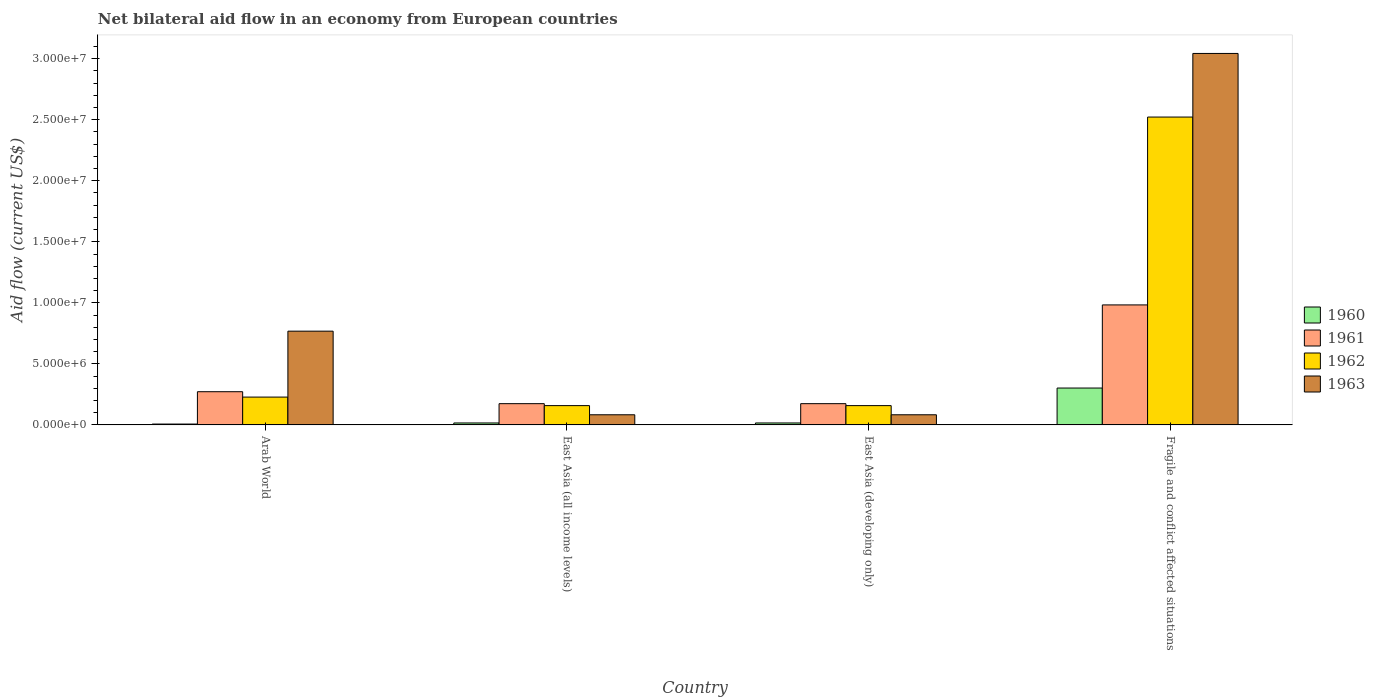How many bars are there on the 4th tick from the left?
Offer a terse response. 4. How many bars are there on the 3rd tick from the right?
Your response must be concise. 4. What is the label of the 2nd group of bars from the left?
Your answer should be compact. East Asia (all income levels). What is the net bilateral aid flow in 1962 in East Asia (developing only)?
Your answer should be compact. 1.58e+06. Across all countries, what is the maximum net bilateral aid flow in 1962?
Your answer should be very brief. 2.52e+07. Across all countries, what is the minimum net bilateral aid flow in 1963?
Provide a short and direct response. 8.30e+05. In which country was the net bilateral aid flow in 1962 maximum?
Offer a terse response. Fragile and conflict affected situations. In which country was the net bilateral aid flow in 1960 minimum?
Ensure brevity in your answer.  Arab World. What is the total net bilateral aid flow in 1961 in the graph?
Ensure brevity in your answer.  1.60e+07. What is the difference between the net bilateral aid flow in 1960 in Arab World and that in Fragile and conflict affected situations?
Your answer should be compact. -2.95e+06. What is the difference between the net bilateral aid flow in 1961 in Fragile and conflict affected situations and the net bilateral aid flow in 1963 in East Asia (all income levels)?
Give a very brief answer. 9.00e+06. What is the average net bilateral aid flow in 1960 per country?
Make the answer very short. 8.52e+05. What is the difference between the net bilateral aid flow of/in 1960 and net bilateral aid flow of/in 1963 in East Asia (developing only)?
Give a very brief answer. -6.70e+05. What is the ratio of the net bilateral aid flow in 1962 in Arab World to that in Fragile and conflict affected situations?
Provide a short and direct response. 0.09. Is the net bilateral aid flow in 1962 in East Asia (developing only) less than that in Fragile and conflict affected situations?
Provide a short and direct response. Yes. What is the difference between the highest and the second highest net bilateral aid flow in 1961?
Offer a terse response. 7.11e+06. What is the difference between the highest and the lowest net bilateral aid flow in 1961?
Your answer should be very brief. 8.09e+06. What does the 2nd bar from the left in Fragile and conflict affected situations represents?
Offer a very short reply. 1961. How many bars are there?
Give a very brief answer. 16. Are the values on the major ticks of Y-axis written in scientific E-notation?
Offer a very short reply. Yes. How many legend labels are there?
Provide a short and direct response. 4. What is the title of the graph?
Keep it short and to the point. Net bilateral aid flow in an economy from European countries. What is the label or title of the Y-axis?
Make the answer very short. Aid flow (current US$). What is the Aid flow (current US$) of 1961 in Arab World?
Provide a succinct answer. 2.72e+06. What is the Aid flow (current US$) in 1962 in Arab World?
Provide a succinct answer. 2.28e+06. What is the Aid flow (current US$) in 1963 in Arab World?
Make the answer very short. 7.68e+06. What is the Aid flow (current US$) of 1960 in East Asia (all income levels)?
Keep it short and to the point. 1.60e+05. What is the Aid flow (current US$) of 1961 in East Asia (all income levels)?
Provide a short and direct response. 1.74e+06. What is the Aid flow (current US$) in 1962 in East Asia (all income levels)?
Ensure brevity in your answer.  1.58e+06. What is the Aid flow (current US$) in 1963 in East Asia (all income levels)?
Give a very brief answer. 8.30e+05. What is the Aid flow (current US$) of 1961 in East Asia (developing only)?
Offer a terse response. 1.74e+06. What is the Aid flow (current US$) of 1962 in East Asia (developing only)?
Your response must be concise. 1.58e+06. What is the Aid flow (current US$) in 1963 in East Asia (developing only)?
Offer a very short reply. 8.30e+05. What is the Aid flow (current US$) of 1960 in Fragile and conflict affected situations?
Ensure brevity in your answer.  3.02e+06. What is the Aid flow (current US$) of 1961 in Fragile and conflict affected situations?
Provide a succinct answer. 9.83e+06. What is the Aid flow (current US$) of 1962 in Fragile and conflict affected situations?
Offer a terse response. 2.52e+07. What is the Aid flow (current US$) of 1963 in Fragile and conflict affected situations?
Your response must be concise. 3.04e+07. Across all countries, what is the maximum Aid flow (current US$) in 1960?
Provide a succinct answer. 3.02e+06. Across all countries, what is the maximum Aid flow (current US$) in 1961?
Provide a succinct answer. 9.83e+06. Across all countries, what is the maximum Aid flow (current US$) of 1962?
Your response must be concise. 2.52e+07. Across all countries, what is the maximum Aid flow (current US$) of 1963?
Your response must be concise. 3.04e+07. Across all countries, what is the minimum Aid flow (current US$) in 1961?
Keep it short and to the point. 1.74e+06. Across all countries, what is the minimum Aid flow (current US$) of 1962?
Offer a very short reply. 1.58e+06. Across all countries, what is the minimum Aid flow (current US$) in 1963?
Provide a succinct answer. 8.30e+05. What is the total Aid flow (current US$) in 1960 in the graph?
Ensure brevity in your answer.  3.41e+06. What is the total Aid flow (current US$) of 1961 in the graph?
Offer a very short reply. 1.60e+07. What is the total Aid flow (current US$) in 1962 in the graph?
Your response must be concise. 3.07e+07. What is the total Aid flow (current US$) in 1963 in the graph?
Your answer should be very brief. 3.98e+07. What is the difference between the Aid flow (current US$) in 1961 in Arab World and that in East Asia (all income levels)?
Provide a short and direct response. 9.80e+05. What is the difference between the Aid flow (current US$) of 1962 in Arab World and that in East Asia (all income levels)?
Provide a succinct answer. 7.00e+05. What is the difference between the Aid flow (current US$) of 1963 in Arab World and that in East Asia (all income levels)?
Provide a succinct answer. 6.85e+06. What is the difference between the Aid flow (current US$) of 1960 in Arab World and that in East Asia (developing only)?
Provide a short and direct response. -9.00e+04. What is the difference between the Aid flow (current US$) of 1961 in Arab World and that in East Asia (developing only)?
Your answer should be very brief. 9.80e+05. What is the difference between the Aid flow (current US$) in 1962 in Arab World and that in East Asia (developing only)?
Ensure brevity in your answer.  7.00e+05. What is the difference between the Aid flow (current US$) in 1963 in Arab World and that in East Asia (developing only)?
Your answer should be very brief. 6.85e+06. What is the difference between the Aid flow (current US$) in 1960 in Arab World and that in Fragile and conflict affected situations?
Offer a terse response. -2.95e+06. What is the difference between the Aid flow (current US$) in 1961 in Arab World and that in Fragile and conflict affected situations?
Ensure brevity in your answer.  -7.11e+06. What is the difference between the Aid flow (current US$) of 1962 in Arab World and that in Fragile and conflict affected situations?
Your answer should be compact. -2.29e+07. What is the difference between the Aid flow (current US$) of 1963 in Arab World and that in Fragile and conflict affected situations?
Your answer should be very brief. -2.28e+07. What is the difference between the Aid flow (current US$) in 1960 in East Asia (all income levels) and that in East Asia (developing only)?
Give a very brief answer. 0. What is the difference between the Aid flow (current US$) of 1960 in East Asia (all income levels) and that in Fragile and conflict affected situations?
Offer a terse response. -2.86e+06. What is the difference between the Aid flow (current US$) in 1961 in East Asia (all income levels) and that in Fragile and conflict affected situations?
Your response must be concise. -8.09e+06. What is the difference between the Aid flow (current US$) of 1962 in East Asia (all income levels) and that in Fragile and conflict affected situations?
Ensure brevity in your answer.  -2.36e+07. What is the difference between the Aid flow (current US$) of 1963 in East Asia (all income levels) and that in Fragile and conflict affected situations?
Offer a very short reply. -2.96e+07. What is the difference between the Aid flow (current US$) of 1960 in East Asia (developing only) and that in Fragile and conflict affected situations?
Provide a succinct answer. -2.86e+06. What is the difference between the Aid flow (current US$) of 1961 in East Asia (developing only) and that in Fragile and conflict affected situations?
Offer a terse response. -8.09e+06. What is the difference between the Aid flow (current US$) of 1962 in East Asia (developing only) and that in Fragile and conflict affected situations?
Your answer should be compact. -2.36e+07. What is the difference between the Aid flow (current US$) of 1963 in East Asia (developing only) and that in Fragile and conflict affected situations?
Keep it short and to the point. -2.96e+07. What is the difference between the Aid flow (current US$) in 1960 in Arab World and the Aid flow (current US$) in 1961 in East Asia (all income levels)?
Give a very brief answer. -1.67e+06. What is the difference between the Aid flow (current US$) of 1960 in Arab World and the Aid flow (current US$) of 1962 in East Asia (all income levels)?
Keep it short and to the point. -1.51e+06. What is the difference between the Aid flow (current US$) of 1960 in Arab World and the Aid flow (current US$) of 1963 in East Asia (all income levels)?
Make the answer very short. -7.60e+05. What is the difference between the Aid flow (current US$) in 1961 in Arab World and the Aid flow (current US$) in 1962 in East Asia (all income levels)?
Ensure brevity in your answer.  1.14e+06. What is the difference between the Aid flow (current US$) in 1961 in Arab World and the Aid flow (current US$) in 1963 in East Asia (all income levels)?
Keep it short and to the point. 1.89e+06. What is the difference between the Aid flow (current US$) in 1962 in Arab World and the Aid flow (current US$) in 1963 in East Asia (all income levels)?
Your answer should be very brief. 1.45e+06. What is the difference between the Aid flow (current US$) in 1960 in Arab World and the Aid flow (current US$) in 1961 in East Asia (developing only)?
Make the answer very short. -1.67e+06. What is the difference between the Aid flow (current US$) of 1960 in Arab World and the Aid flow (current US$) of 1962 in East Asia (developing only)?
Your answer should be compact. -1.51e+06. What is the difference between the Aid flow (current US$) of 1960 in Arab World and the Aid flow (current US$) of 1963 in East Asia (developing only)?
Give a very brief answer. -7.60e+05. What is the difference between the Aid flow (current US$) of 1961 in Arab World and the Aid flow (current US$) of 1962 in East Asia (developing only)?
Provide a succinct answer. 1.14e+06. What is the difference between the Aid flow (current US$) in 1961 in Arab World and the Aid flow (current US$) in 1963 in East Asia (developing only)?
Your answer should be compact. 1.89e+06. What is the difference between the Aid flow (current US$) of 1962 in Arab World and the Aid flow (current US$) of 1963 in East Asia (developing only)?
Offer a terse response. 1.45e+06. What is the difference between the Aid flow (current US$) in 1960 in Arab World and the Aid flow (current US$) in 1961 in Fragile and conflict affected situations?
Make the answer very short. -9.76e+06. What is the difference between the Aid flow (current US$) in 1960 in Arab World and the Aid flow (current US$) in 1962 in Fragile and conflict affected situations?
Keep it short and to the point. -2.52e+07. What is the difference between the Aid flow (current US$) of 1960 in Arab World and the Aid flow (current US$) of 1963 in Fragile and conflict affected situations?
Offer a very short reply. -3.04e+07. What is the difference between the Aid flow (current US$) in 1961 in Arab World and the Aid flow (current US$) in 1962 in Fragile and conflict affected situations?
Your answer should be very brief. -2.25e+07. What is the difference between the Aid flow (current US$) of 1961 in Arab World and the Aid flow (current US$) of 1963 in Fragile and conflict affected situations?
Make the answer very short. -2.77e+07. What is the difference between the Aid flow (current US$) of 1962 in Arab World and the Aid flow (current US$) of 1963 in Fragile and conflict affected situations?
Ensure brevity in your answer.  -2.82e+07. What is the difference between the Aid flow (current US$) in 1960 in East Asia (all income levels) and the Aid flow (current US$) in 1961 in East Asia (developing only)?
Make the answer very short. -1.58e+06. What is the difference between the Aid flow (current US$) in 1960 in East Asia (all income levels) and the Aid flow (current US$) in 1962 in East Asia (developing only)?
Your answer should be compact. -1.42e+06. What is the difference between the Aid flow (current US$) of 1960 in East Asia (all income levels) and the Aid flow (current US$) of 1963 in East Asia (developing only)?
Provide a succinct answer. -6.70e+05. What is the difference between the Aid flow (current US$) of 1961 in East Asia (all income levels) and the Aid flow (current US$) of 1963 in East Asia (developing only)?
Ensure brevity in your answer.  9.10e+05. What is the difference between the Aid flow (current US$) of 1962 in East Asia (all income levels) and the Aid flow (current US$) of 1963 in East Asia (developing only)?
Offer a terse response. 7.50e+05. What is the difference between the Aid flow (current US$) of 1960 in East Asia (all income levels) and the Aid flow (current US$) of 1961 in Fragile and conflict affected situations?
Offer a terse response. -9.67e+06. What is the difference between the Aid flow (current US$) in 1960 in East Asia (all income levels) and the Aid flow (current US$) in 1962 in Fragile and conflict affected situations?
Your answer should be very brief. -2.51e+07. What is the difference between the Aid flow (current US$) in 1960 in East Asia (all income levels) and the Aid flow (current US$) in 1963 in Fragile and conflict affected situations?
Offer a terse response. -3.03e+07. What is the difference between the Aid flow (current US$) of 1961 in East Asia (all income levels) and the Aid flow (current US$) of 1962 in Fragile and conflict affected situations?
Your response must be concise. -2.35e+07. What is the difference between the Aid flow (current US$) in 1961 in East Asia (all income levels) and the Aid flow (current US$) in 1963 in Fragile and conflict affected situations?
Keep it short and to the point. -2.87e+07. What is the difference between the Aid flow (current US$) of 1962 in East Asia (all income levels) and the Aid flow (current US$) of 1963 in Fragile and conflict affected situations?
Offer a very short reply. -2.88e+07. What is the difference between the Aid flow (current US$) in 1960 in East Asia (developing only) and the Aid flow (current US$) in 1961 in Fragile and conflict affected situations?
Your answer should be very brief. -9.67e+06. What is the difference between the Aid flow (current US$) in 1960 in East Asia (developing only) and the Aid flow (current US$) in 1962 in Fragile and conflict affected situations?
Provide a succinct answer. -2.51e+07. What is the difference between the Aid flow (current US$) of 1960 in East Asia (developing only) and the Aid flow (current US$) of 1963 in Fragile and conflict affected situations?
Give a very brief answer. -3.03e+07. What is the difference between the Aid flow (current US$) of 1961 in East Asia (developing only) and the Aid flow (current US$) of 1962 in Fragile and conflict affected situations?
Make the answer very short. -2.35e+07. What is the difference between the Aid flow (current US$) of 1961 in East Asia (developing only) and the Aid flow (current US$) of 1963 in Fragile and conflict affected situations?
Ensure brevity in your answer.  -2.87e+07. What is the difference between the Aid flow (current US$) in 1962 in East Asia (developing only) and the Aid flow (current US$) in 1963 in Fragile and conflict affected situations?
Give a very brief answer. -2.88e+07. What is the average Aid flow (current US$) in 1960 per country?
Your response must be concise. 8.52e+05. What is the average Aid flow (current US$) in 1961 per country?
Offer a very short reply. 4.01e+06. What is the average Aid flow (current US$) of 1962 per country?
Ensure brevity in your answer.  7.66e+06. What is the average Aid flow (current US$) of 1963 per country?
Provide a short and direct response. 9.94e+06. What is the difference between the Aid flow (current US$) of 1960 and Aid flow (current US$) of 1961 in Arab World?
Your answer should be very brief. -2.65e+06. What is the difference between the Aid flow (current US$) of 1960 and Aid flow (current US$) of 1962 in Arab World?
Make the answer very short. -2.21e+06. What is the difference between the Aid flow (current US$) of 1960 and Aid flow (current US$) of 1963 in Arab World?
Ensure brevity in your answer.  -7.61e+06. What is the difference between the Aid flow (current US$) of 1961 and Aid flow (current US$) of 1962 in Arab World?
Your answer should be very brief. 4.40e+05. What is the difference between the Aid flow (current US$) in 1961 and Aid flow (current US$) in 1963 in Arab World?
Give a very brief answer. -4.96e+06. What is the difference between the Aid flow (current US$) in 1962 and Aid flow (current US$) in 1963 in Arab World?
Your response must be concise. -5.40e+06. What is the difference between the Aid flow (current US$) in 1960 and Aid flow (current US$) in 1961 in East Asia (all income levels)?
Your response must be concise. -1.58e+06. What is the difference between the Aid flow (current US$) of 1960 and Aid flow (current US$) of 1962 in East Asia (all income levels)?
Your answer should be very brief. -1.42e+06. What is the difference between the Aid flow (current US$) of 1960 and Aid flow (current US$) of 1963 in East Asia (all income levels)?
Keep it short and to the point. -6.70e+05. What is the difference between the Aid flow (current US$) in 1961 and Aid flow (current US$) in 1962 in East Asia (all income levels)?
Your answer should be very brief. 1.60e+05. What is the difference between the Aid flow (current US$) of 1961 and Aid flow (current US$) of 1963 in East Asia (all income levels)?
Give a very brief answer. 9.10e+05. What is the difference between the Aid flow (current US$) in 1962 and Aid flow (current US$) in 1963 in East Asia (all income levels)?
Ensure brevity in your answer.  7.50e+05. What is the difference between the Aid flow (current US$) in 1960 and Aid flow (current US$) in 1961 in East Asia (developing only)?
Give a very brief answer. -1.58e+06. What is the difference between the Aid flow (current US$) of 1960 and Aid flow (current US$) of 1962 in East Asia (developing only)?
Offer a very short reply. -1.42e+06. What is the difference between the Aid flow (current US$) in 1960 and Aid flow (current US$) in 1963 in East Asia (developing only)?
Your response must be concise. -6.70e+05. What is the difference between the Aid flow (current US$) of 1961 and Aid flow (current US$) of 1962 in East Asia (developing only)?
Provide a succinct answer. 1.60e+05. What is the difference between the Aid flow (current US$) in 1961 and Aid flow (current US$) in 1963 in East Asia (developing only)?
Provide a succinct answer. 9.10e+05. What is the difference between the Aid flow (current US$) in 1962 and Aid flow (current US$) in 1963 in East Asia (developing only)?
Offer a terse response. 7.50e+05. What is the difference between the Aid flow (current US$) in 1960 and Aid flow (current US$) in 1961 in Fragile and conflict affected situations?
Offer a very short reply. -6.81e+06. What is the difference between the Aid flow (current US$) of 1960 and Aid flow (current US$) of 1962 in Fragile and conflict affected situations?
Make the answer very short. -2.22e+07. What is the difference between the Aid flow (current US$) in 1960 and Aid flow (current US$) in 1963 in Fragile and conflict affected situations?
Your answer should be very brief. -2.74e+07. What is the difference between the Aid flow (current US$) in 1961 and Aid flow (current US$) in 1962 in Fragile and conflict affected situations?
Your response must be concise. -1.54e+07. What is the difference between the Aid flow (current US$) of 1961 and Aid flow (current US$) of 1963 in Fragile and conflict affected situations?
Offer a very short reply. -2.06e+07. What is the difference between the Aid flow (current US$) of 1962 and Aid flow (current US$) of 1963 in Fragile and conflict affected situations?
Offer a very short reply. -5.21e+06. What is the ratio of the Aid flow (current US$) of 1960 in Arab World to that in East Asia (all income levels)?
Ensure brevity in your answer.  0.44. What is the ratio of the Aid flow (current US$) in 1961 in Arab World to that in East Asia (all income levels)?
Your answer should be very brief. 1.56. What is the ratio of the Aid flow (current US$) of 1962 in Arab World to that in East Asia (all income levels)?
Ensure brevity in your answer.  1.44. What is the ratio of the Aid flow (current US$) in 1963 in Arab World to that in East Asia (all income levels)?
Make the answer very short. 9.25. What is the ratio of the Aid flow (current US$) in 1960 in Arab World to that in East Asia (developing only)?
Offer a very short reply. 0.44. What is the ratio of the Aid flow (current US$) in 1961 in Arab World to that in East Asia (developing only)?
Make the answer very short. 1.56. What is the ratio of the Aid flow (current US$) in 1962 in Arab World to that in East Asia (developing only)?
Ensure brevity in your answer.  1.44. What is the ratio of the Aid flow (current US$) of 1963 in Arab World to that in East Asia (developing only)?
Keep it short and to the point. 9.25. What is the ratio of the Aid flow (current US$) in 1960 in Arab World to that in Fragile and conflict affected situations?
Your answer should be compact. 0.02. What is the ratio of the Aid flow (current US$) of 1961 in Arab World to that in Fragile and conflict affected situations?
Offer a very short reply. 0.28. What is the ratio of the Aid flow (current US$) in 1962 in Arab World to that in Fragile and conflict affected situations?
Ensure brevity in your answer.  0.09. What is the ratio of the Aid flow (current US$) of 1963 in Arab World to that in Fragile and conflict affected situations?
Your answer should be very brief. 0.25. What is the ratio of the Aid flow (current US$) of 1960 in East Asia (all income levels) to that in East Asia (developing only)?
Keep it short and to the point. 1. What is the ratio of the Aid flow (current US$) of 1962 in East Asia (all income levels) to that in East Asia (developing only)?
Give a very brief answer. 1. What is the ratio of the Aid flow (current US$) in 1960 in East Asia (all income levels) to that in Fragile and conflict affected situations?
Provide a succinct answer. 0.05. What is the ratio of the Aid flow (current US$) in 1961 in East Asia (all income levels) to that in Fragile and conflict affected situations?
Provide a short and direct response. 0.18. What is the ratio of the Aid flow (current US$) in 1962 in East Asia (all income levels) to that in Fragile and conflict affected situations?
Your response must be concise. 0.06. What is the ratio of the Aid flow (current US$) in 1963 in East Asia (all income levels) to that in Fragile and conflict affected situations?
Your answer should be very brief. 0.03. What is the ratio of the Aid flow (current US$) in 1960 in East Asia (developing only) to that in Fragile and conflict affected situations?
Make the answer very short. 0.05. What is the ratio of the Aid flow (current US$) of 1961 in East Asia (developing only) to that in Fragile and conflict affected situations?
Ensure brevity in your answer.  0.18. What is the ratio of the Aid flow (current US$) of 1962 in East Asia (developing only) to that in Fragile and conflict affected situations?
Give a very brief answer. 0.06. What is the ratio of the Aid flow (current US$) of 1963 in East Asia (developing only) to that in Fragile and conflict affected situations?
Make the answer very short. 0.03. What is the difference between the highest and the second highest Aid flow (current US$) in 1960?
Keep it short and to the point. 2.86e+06. What is the difference between the highest and the second highest Aid flow (current US$) in 1961?
Offer a very short reply. 7.11e+06. What is the difference between the highest and the second highest Aid flow (current US$) in 1962?
Your answer should be very brief. 2.29e+07. What is the difference between the highest and the second highest Aid flow (current US$) of 1963?
Offer a very short reply. 2.28e+07. What is the difference between the highest and the lowest Aid flow (current US$) in 1960?
Ensure brevity in your answer.  2.95e+06. What is the difference between the highest and the lowest Aid flow (current US$) in 1961?
Your response must be concise. 8.09e+06. What is the difference between the highest and the lowest Aid flow (current US$) of 1962?
Provide a short and direct response. 2.36e+07. What is the difference between the highest and the lowest Aid flow (current US$) of 1963?
Make the answer very short. 2.96e+07. 